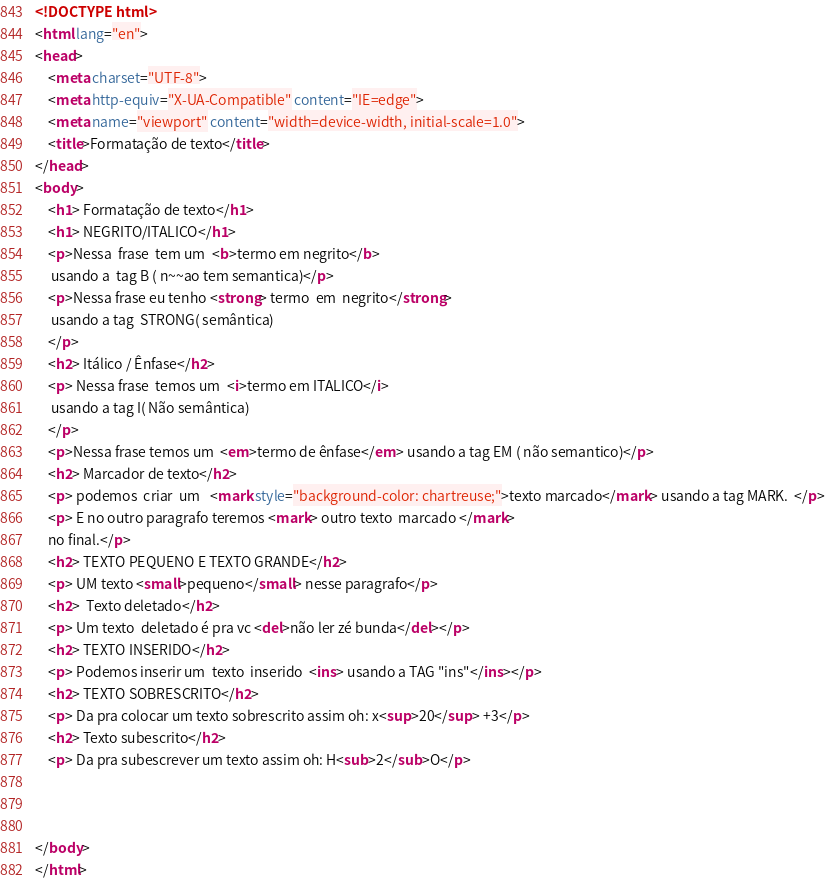<code> <loc_0><loc_0><loc_500><loc_500><_HTML_><!DOCTYPE html>
<html lang="en">
<head>
    <meta charset="UTF-8">
    <meta http-equiv="X-UA-Compatible" content="IE=edge">
    <meta name="viewport" content="width=device-width, initial-scale=1.0">
    <title>Formatação de texto</title>
</head>
<body>
    <h1> Formatação de texto</h1>
    <h1> NEGRITO/ITALICO</h1>
    <p>Nessa  frase  tem um  <b>termo em negrito</b> 
     usando a  tag B ( n~~ao tem semantica)</p>
    <p>Nessa frase eu tenho <strong> termo  em  negrito</strong>
     usando a tag  STRONG( semântica)
    </p>
    <h2> Itálico / Ênfase</h2>
    <p> Nessa frase  temos um  <i>termo em ITALICO</i>
     usando a tag I( Não semântica)
    </p>
    <p>Nessa frase temos um  <em>termo de ênfase</em> usando a tag EM ( não semantico)</p>
    <h2> Marcador de texto</h2>
    <p> podemos  criar  um   <mark style="background-color: chartreuse;">texto marcado</mark> usando a tag MARK.  </p>
    <p> E no outro paragrafo teremos <mark> outro texto  marcado </mark> 
    no final.</p>
    <h2> TEXTO PEQUENO E TEXTO GRANDE</h2>
    <p> UM texto <small>pequeno</small> nesse paragrafo</p>
    <h2>  Texto deletado</h2>
    <p> Um texto  deletado é pra vc <del>não ler zé bunda</del></p>
    <h2> TEXTO INSERIDO</h2>
    <p> Podemos inserir um  texto  inserido  <ins> usando a TAG "ins"</ins></p>
    <h2> TEXTO SOBRESCRITO</h2>
    <p> Da pra colocar um texto sobrescrito assim oh: x<sup>20</sup> +3</p>
    <h2> Texto subescrito</h2>
    <p> Da pra subescrever um texto assim oh: H<sub>2</sub>O</p>


    
</body>
</html></code> 